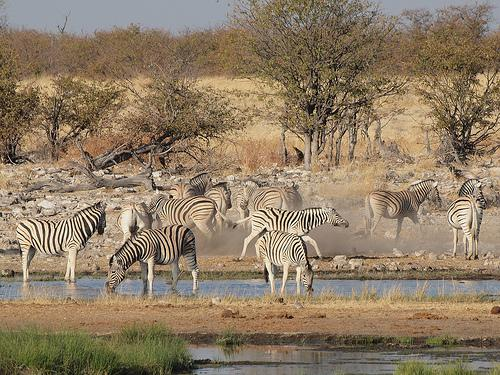Question: what animal species is pictured?
Choices:
A. Elephant.
B. Snake.
C. Zebra.
D. Horse.
Answer with the letter. Answer: C Question: what are the zebras that are drinking standing in?
Choices:
A. Mud.
B. River.
C. A pond.
D. Pen.
Answer with the letter. Answer: C Question: where was this photographed?
Choices:
A. Ohio.
B. Africa.
C. Las Vegas.
D. Base of volcano.
Answer with the letter. Answer: B Question: how many zebras are standing in the water?
Choices:
A. Three.
B. Two.
C. One.
D. Four.
Answer with the letter. Answer: A 